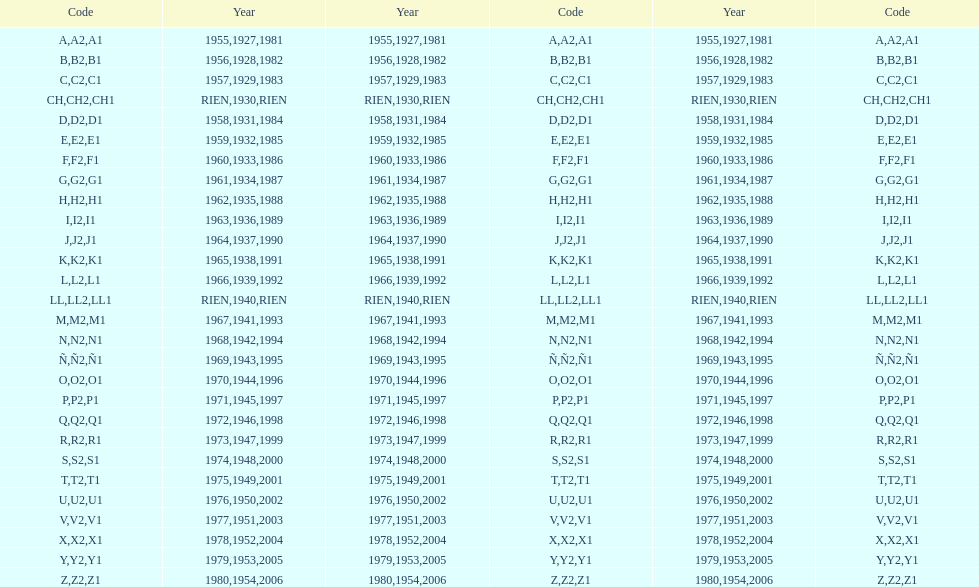Is the e-code lesser than 1950? Yes. 